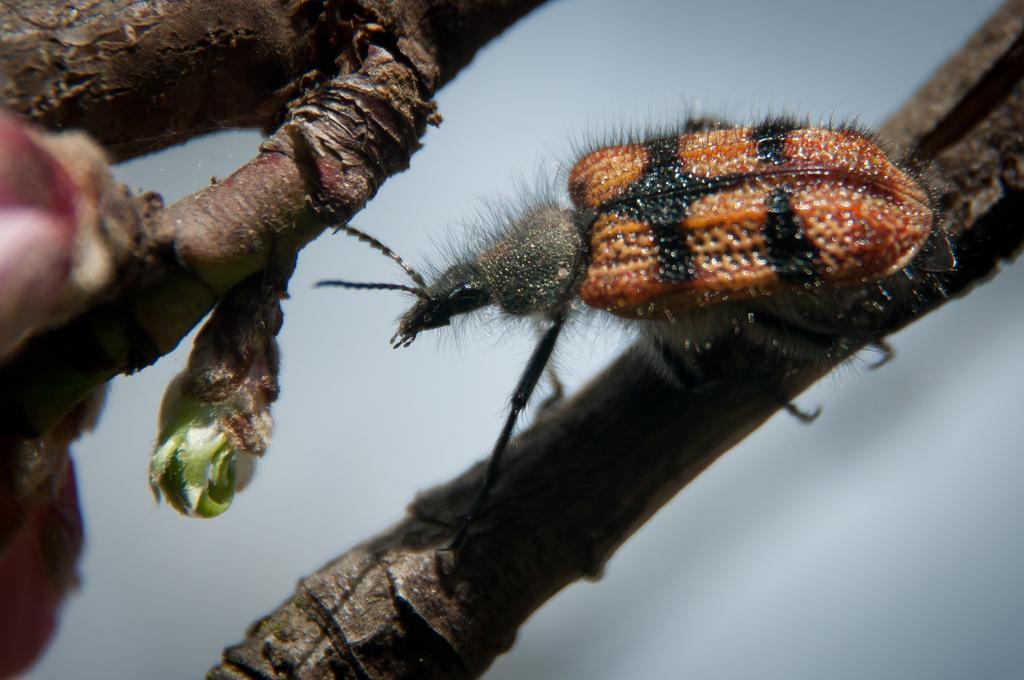Describe this image in one or two sentences. In this picture we can see branches of a plant, there is an insect in the middle, on the left side we can see a bud. 